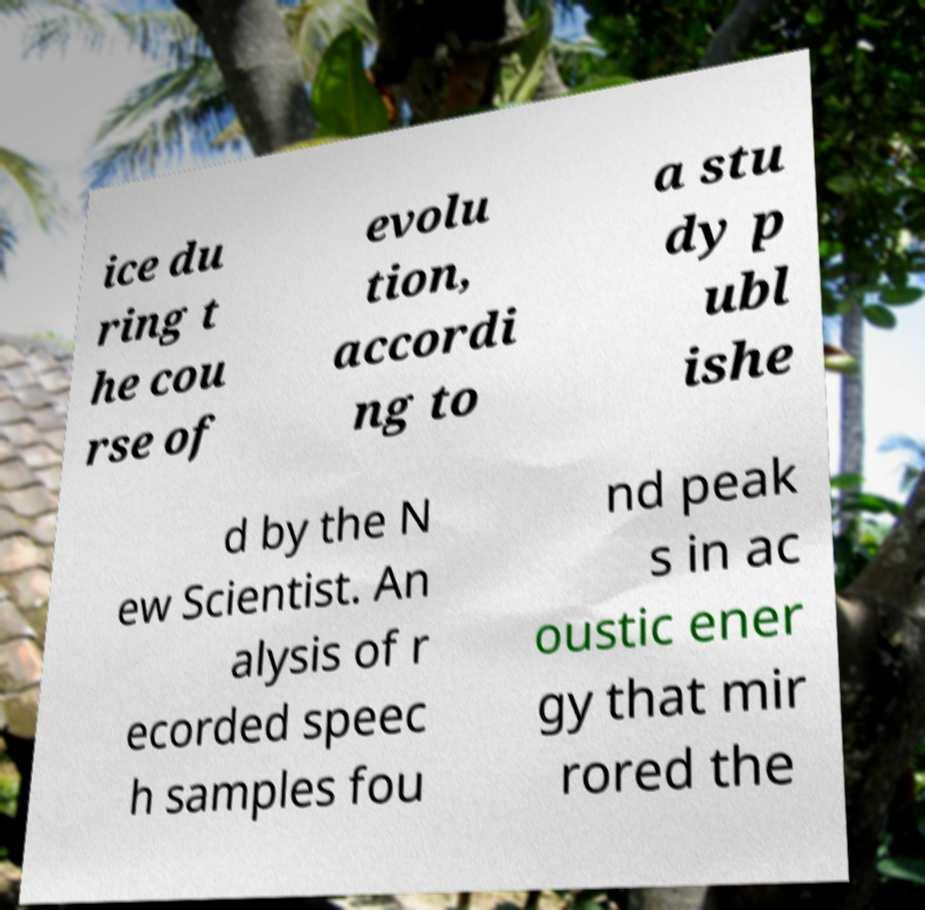There's text embedded in this image that I need extracted. Can you transcribe it verbatim? ice du ring t he cou rse of evolu tion, accordi ng to a stu dy p ubl ishe d by the N ew Scientist. An alysis of r ecorded speec h samples fou nd peak s in ac oustic ener gy that mir rored the 